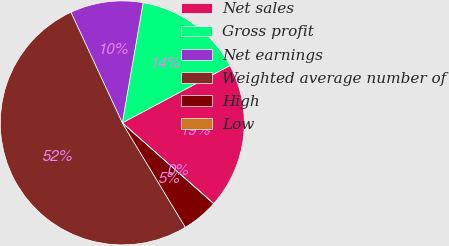Convert chart. <chart><loc_0><loc_0><loc_500><loc_500><pie_chart><fcel>Net sales<fcel>Gross profit<fcel>Net earnings<fcel>Weighted average number of<fcel>High<fcel>Low<nl><fcel>19.31%<fcel>14.48%<fcel>9.65%<fcel>51.73%<fcel>4.83%<fcel>0.0%<nl></chart> 